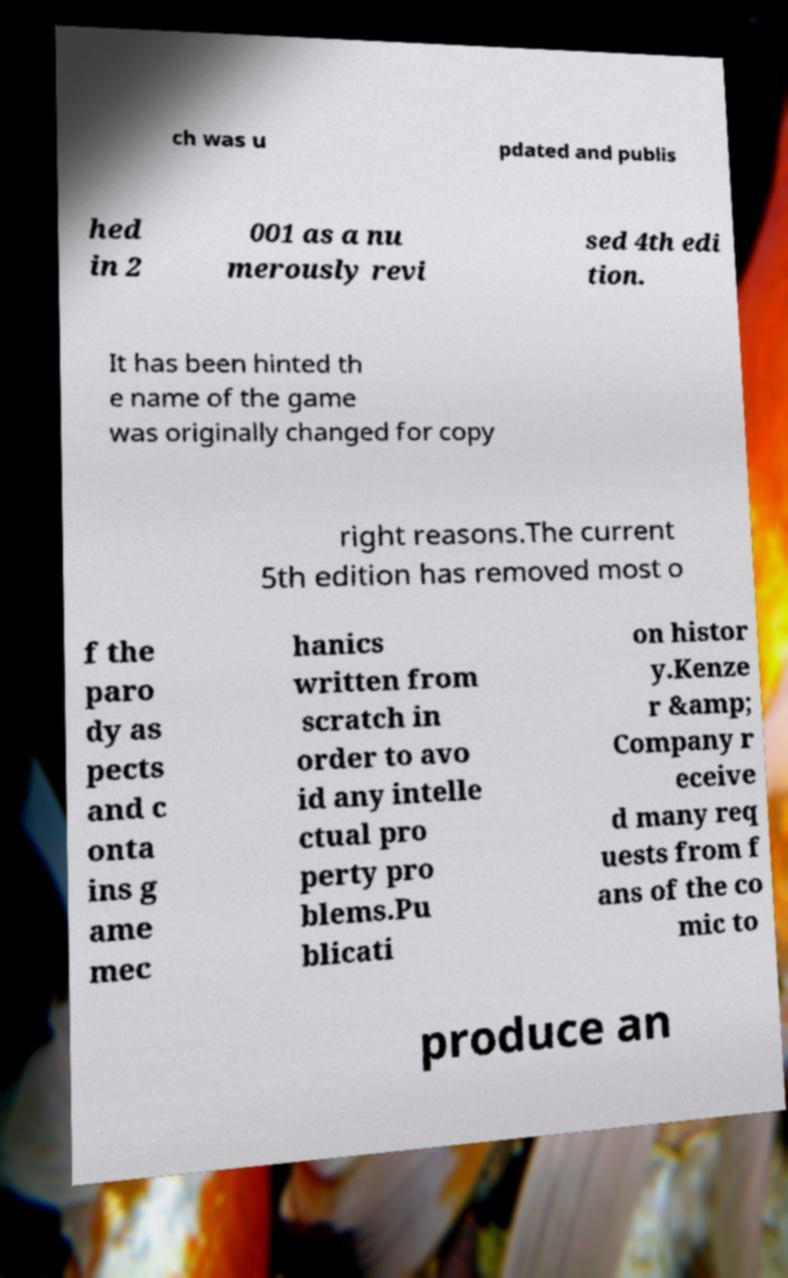Can you read and provide the text displayed in the image?This photo seems to have some interesting text. Can you extract and type it out for me? ch was u pdated and publis hed in 2 001 as a nu merously revi sed 4th edi tion. It has been hinted th e name of the game was originally changed for copy right reasons.The current 5th edition has removed most o f the paro dy as pects and c onta ins g ame mec hanics written from scratch in order to avo id any intelle ctual pro perty pro blems.Pu blicati on histor y.Kenze r &amp; Company r eceive d many req uests from f ans of the co mic to produce an 